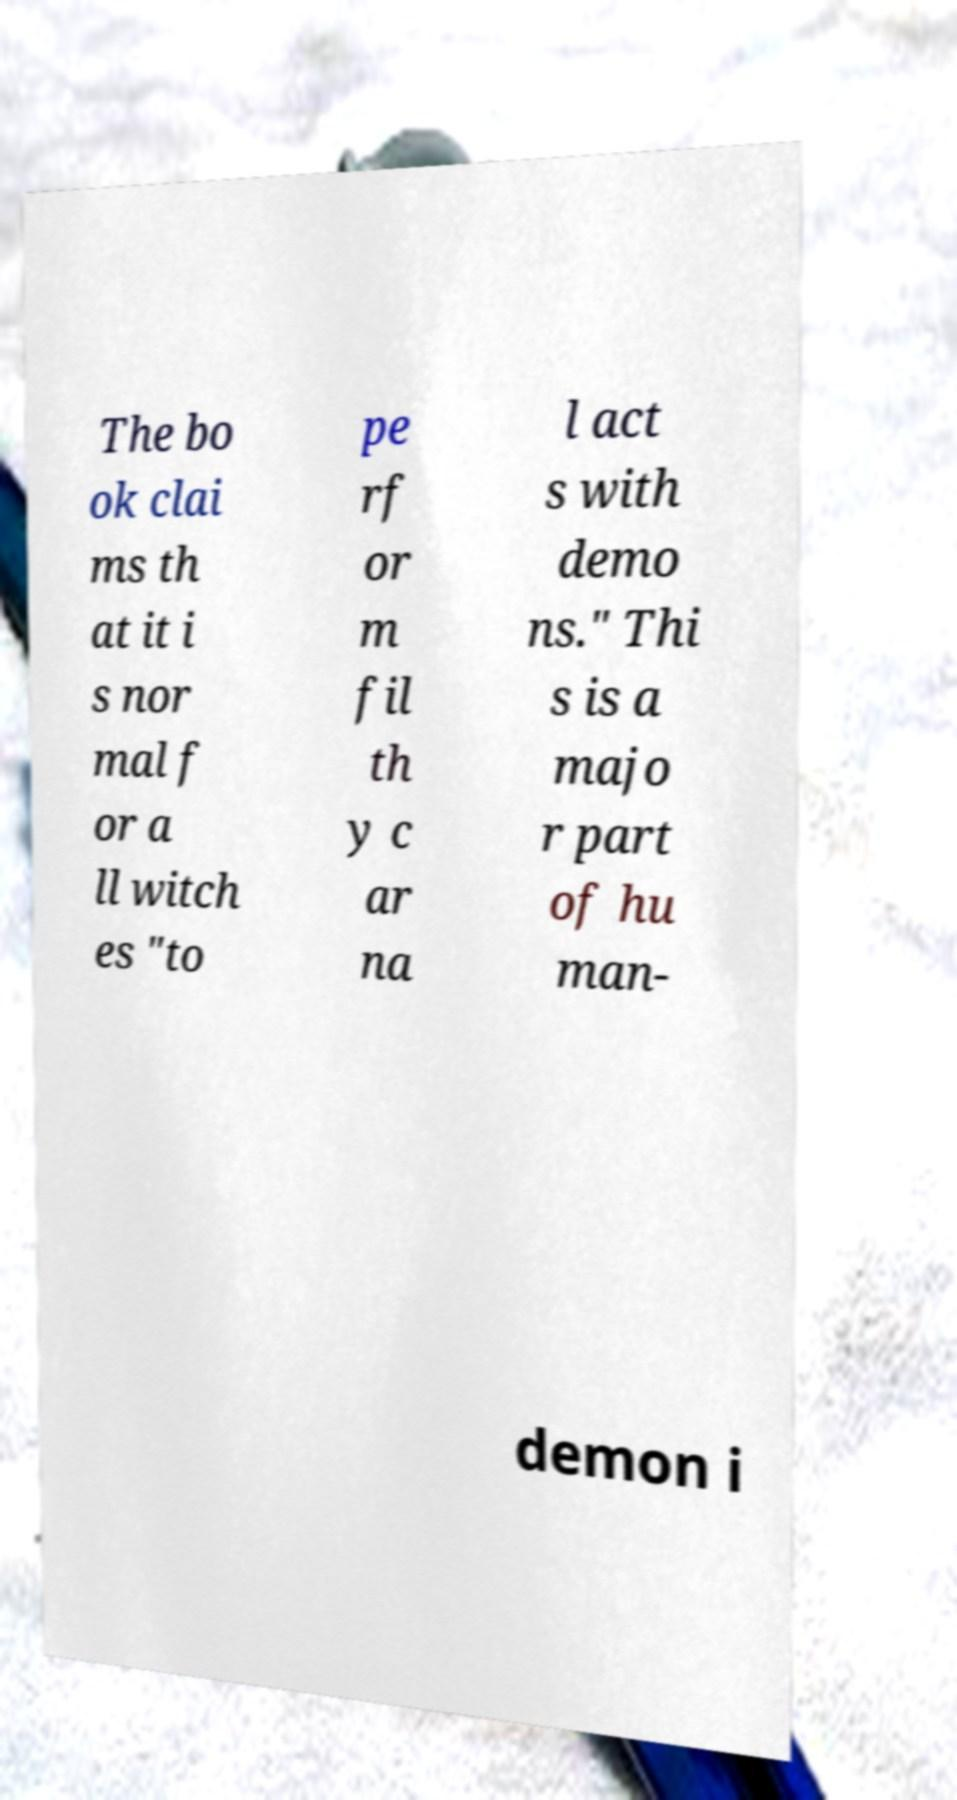There's text embedded in this image that I need extracted. Can you transcribe it verbatim? The bo ok clai ms th at it i s nor mal f or a ll witch es "to pe rf or m fil th y c ar na l act s with demo ns." Thi s is a majo r part of hu man- demon i 